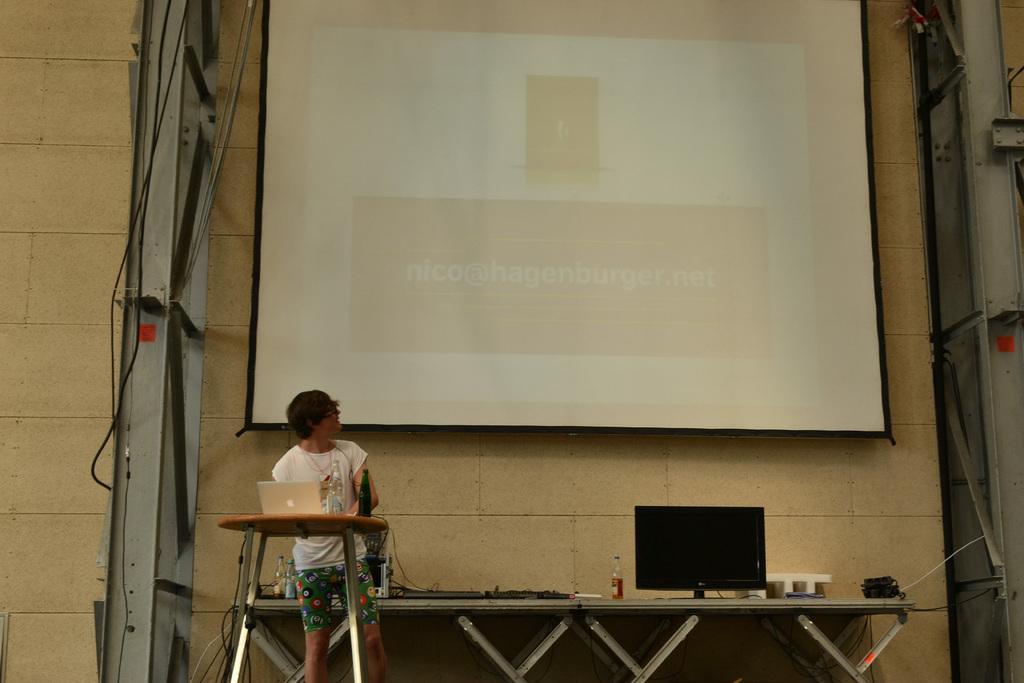In one or two sentences, can you explain what this image depicts? In the picture we can see a woman standing and in front of her we can see a table with laptop and bottle on it and behind her we can see a table with computer, bottle and some things are placed and behind it we can see a wall with screen with some information projecting on it and besides the screen we can see a metal stands. 